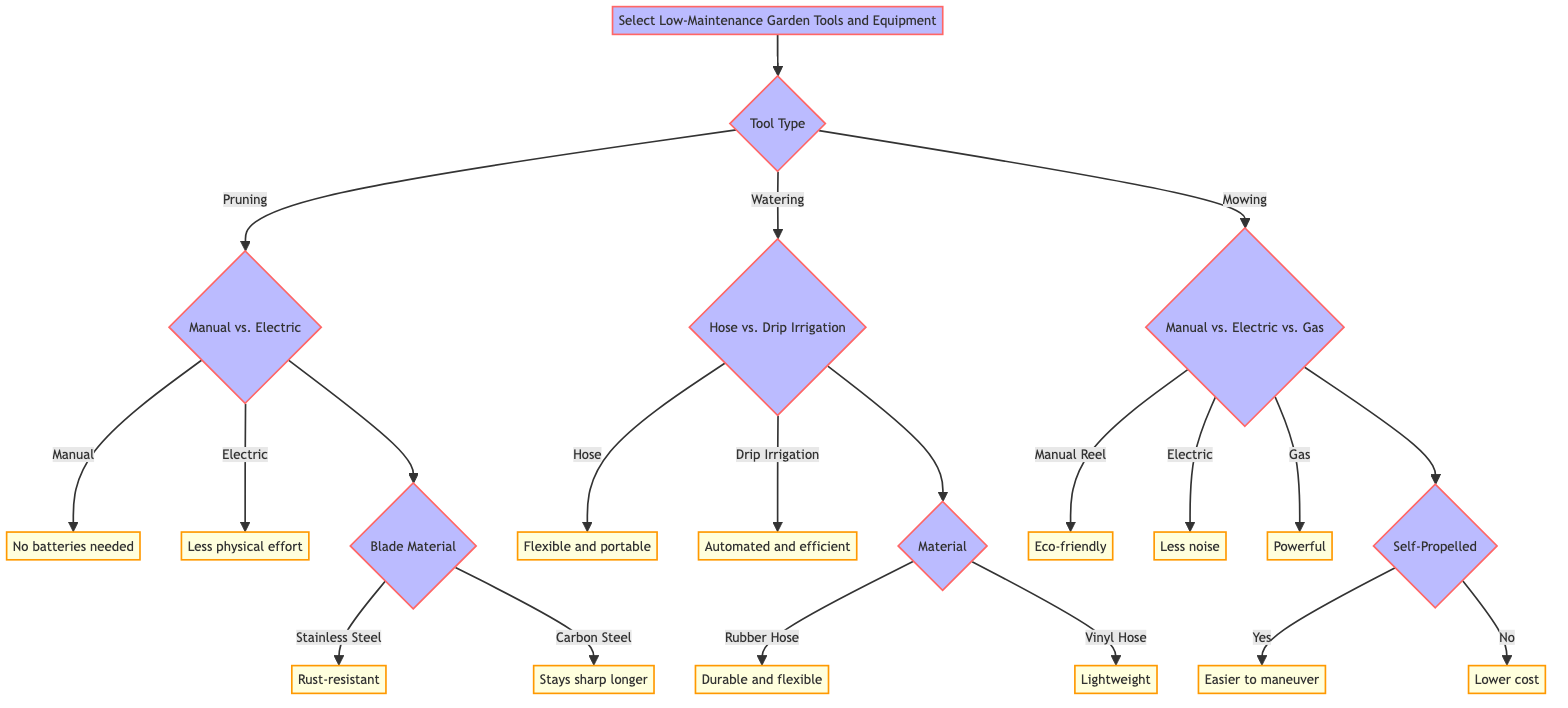What is the main decision of the diagram? The main decision of the diagram is to select low-maintenance garden tools and equipment.
Answer: Select Low-Maintenance Garden Tools and Equipment How many tool types are indicated in the diagram? There are three tool types indicated in the diagram: Pruning, Watering, and Mowing.
Answer: Three What is one benefit of using an electric mower? One benefit of using an electric mower is less noise and maintenance.
Answer: Less noise What factors are considered under the pruning option? The factors considered under the pruning option are Manual vs. Electric and Blade Material.
Answer: Manual vs. Electric and Blade Material If you choose a hose for watering, what is a benefit? A benefit of choosing a hose for watering is that it is flexible and portable.
Answer: Flexible and portable What happens if you select carbon steel for blade material? If you select carbon steel for blade material, it stays sharp longer but requires more maintenance to avoid rust.
Answer: Stays sharp longer What type of watering system is automated and above a certain cost? The type of watering system that is automated and has a higher initial setup cost is drip irrigation.
Answer: Drip Irrigation Which mowing option requires physical effort? The option that requires physical effort is the Manual Reel Mower.
Answer: Manual Reel Mower What does having a self-propelled mower offer? Having a self-propelled mower offers easier maneuverability and requires less effort.
Answer: Easier to maneuver How does a rubber hose differ from a vinyl hose? A rubber hose is durable and flexible, while a vinyl hose is lightweight and easy to use but less durable.
Answer: Durable and flexible vs. Lightweight and easy to use 